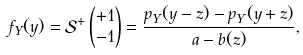Convert formula to latex. <formula><loc_0><loc_0><loc_500><loc_500>f _ { Y } ( y ) & = \mathcal { S } ^ { + } \begin{pmatrix} + 1 \\ - 1 \end{pmatrix} = \frac { p _ { Y } ( y - z ) - p _ { Y } ( y + z ) } { a - b ( z ) } ,</formula> 